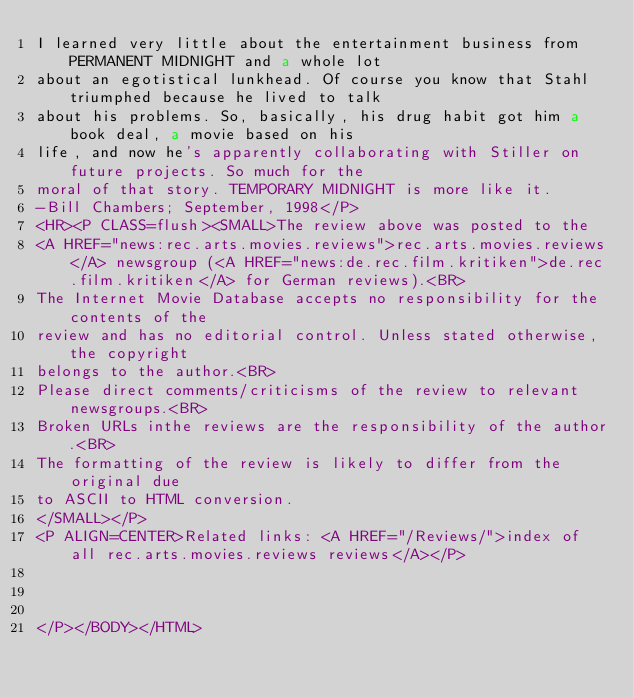Convert code to text. <code><loc_0><loc_0><loc_500><loc_500><_HTML_>I learned very little about the entertainment business from PERMANENT MIDNIGHT and a whole lot
about an egotistical lunkhead. Of course you know that Stahl triumphed because he lived to talk
about his problems. So, basically, his drug habit got him a book deal, a movie based on his
life, and now he's apparently collaborating with Stiller on future projects. So much for the
moral of that story. TEMPORARY MIDNIGHT is more like it.
-Bill Chambers; September, 1998</P>
<HR><P CLASS=flush><SMALL>The review above was posted to the
<A HREF="news:rec.arts.movies.reviews">rec.arts.movies.reviews</A> newsgroup (<A HREF="news:de.rec.film.kritiken">de.rec.film.kritiken</A> for German reviews).<BR>
The Internet Movie Database accepts no responsibility for the contents of the
review and has no editorial control. Unless stated otherwise, the copyright
belongs to the author.<BR>
Please direct comments/criticisms of the review to relevant newsgroups.<BR>
Broken URLs inthe reviews are the responsibility of the author.<BR>
The formatting of the review is likely to differ from the original due
to ASCII to HTML conversion.
</SMALL></P>
<P ALIGN=CENTER>Related links: <A HREF="/Reviews/">index of all rec.arts.movies.reviews reviews</A></P>



</P></BODY></HTML>
</code> 